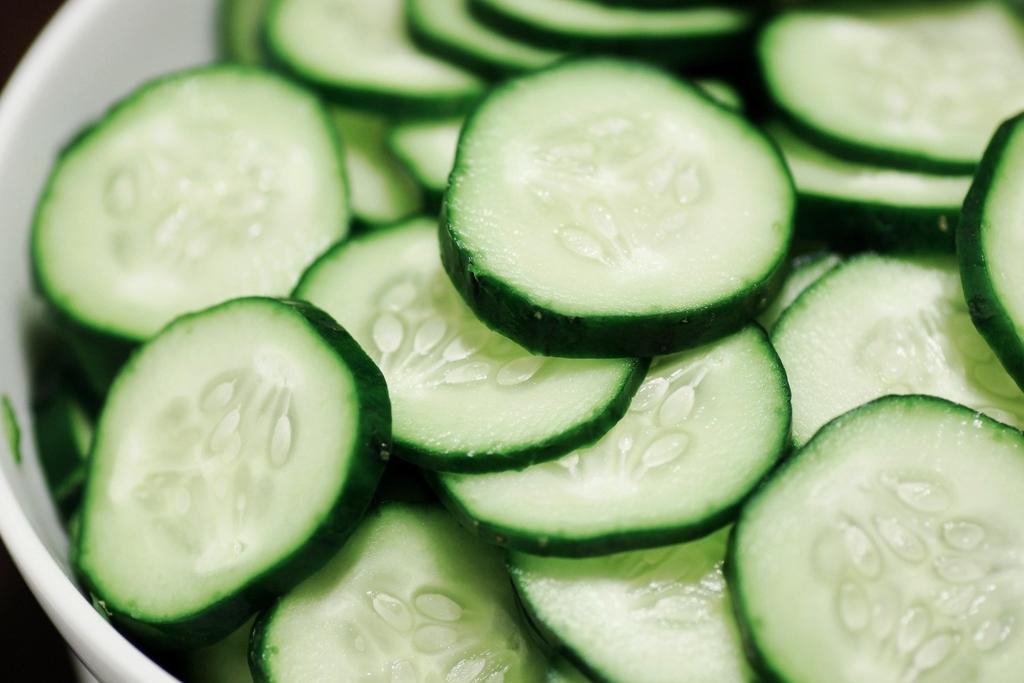How would you summarize this image in a sentence or two? In this picture, we see a white bowl containing chopped cucumbers. 